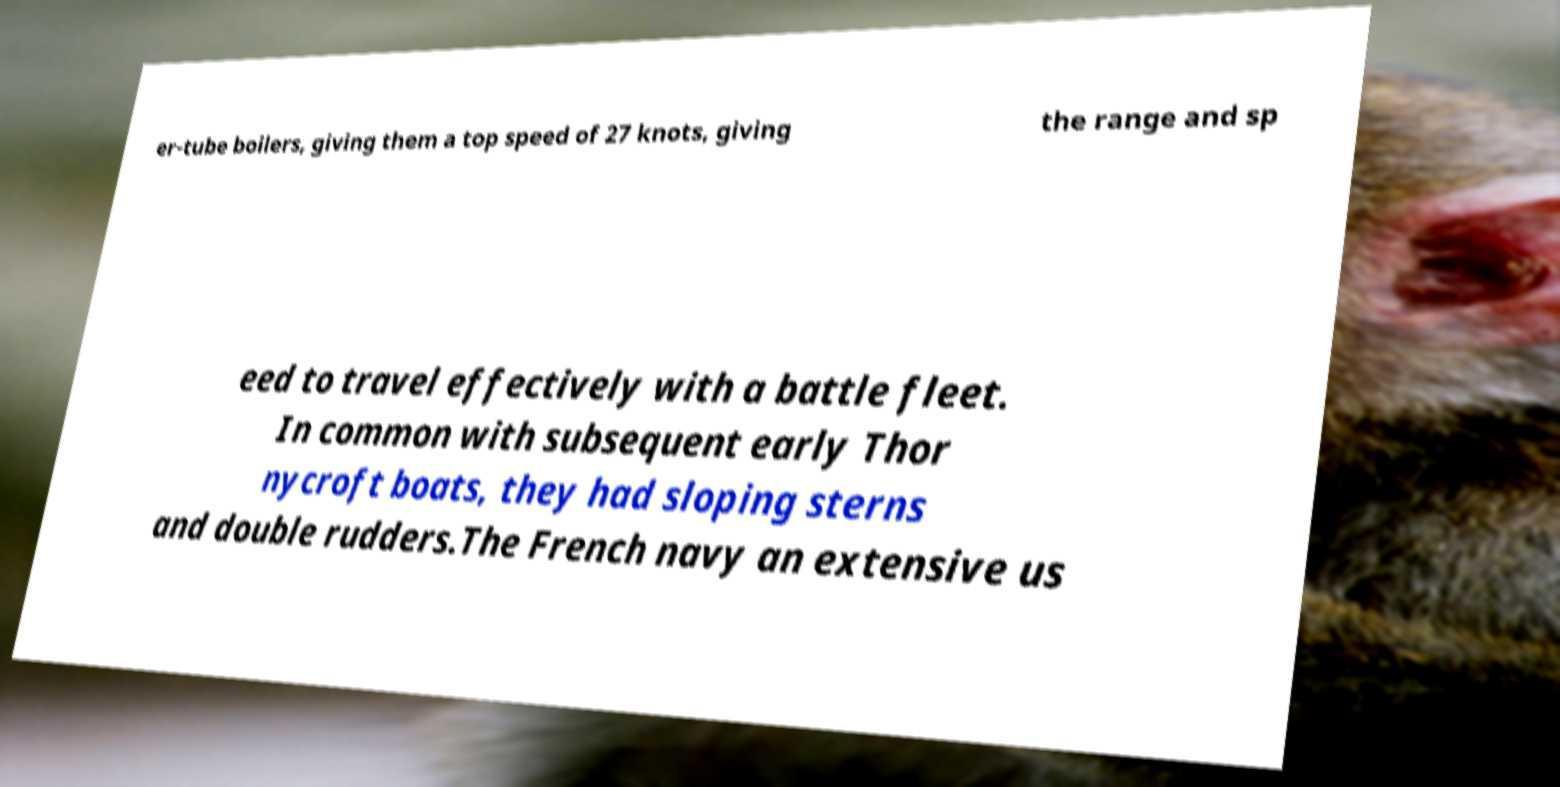There's text embedded in this image that I need extracted. Can you transcribe it verbatim? er-tube boilers, giving them a top speed of 27 knots, giving the range and sp eed to travel effectively with a battle fleet. In common with subsequent early Thor nycroft boats, they had sloping sterns and double rudders.The French navy an extensive us 